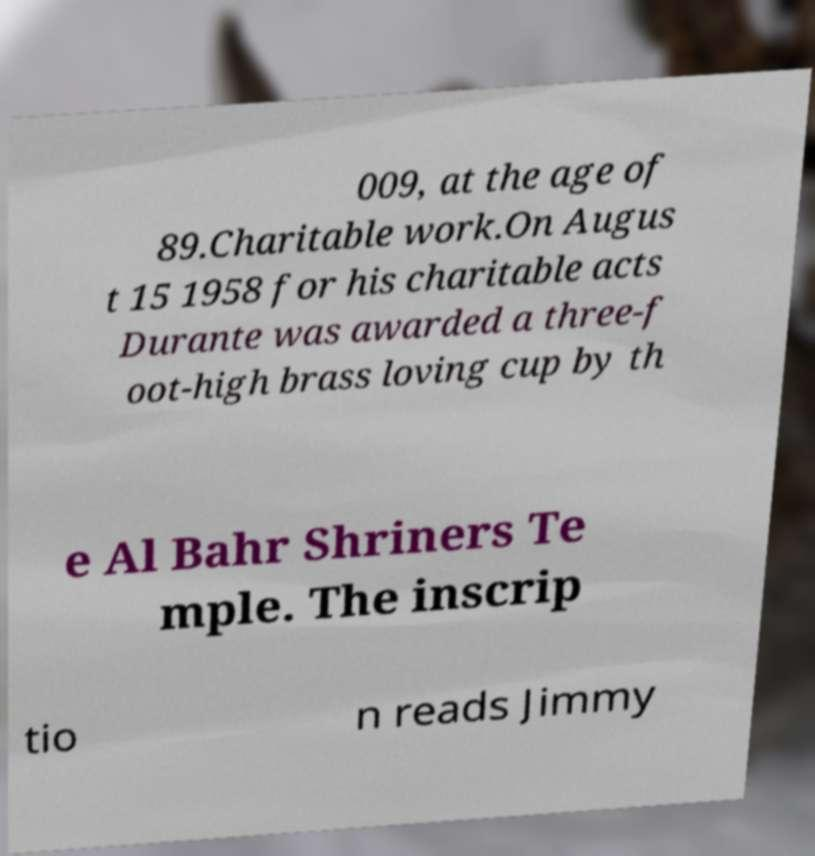Can you read and provide the text displayed in the image?This photo seems to have some interesting text. Can you extract and type it out for me? 009, at the age of 89.Charitable work.On Augus t 15 1958 for his charitable acts Durante was awarded a three-f oot-high brass loving cup by th e Al Bahr Shriners Te mple. The inscrip tio n reads Jimmy 